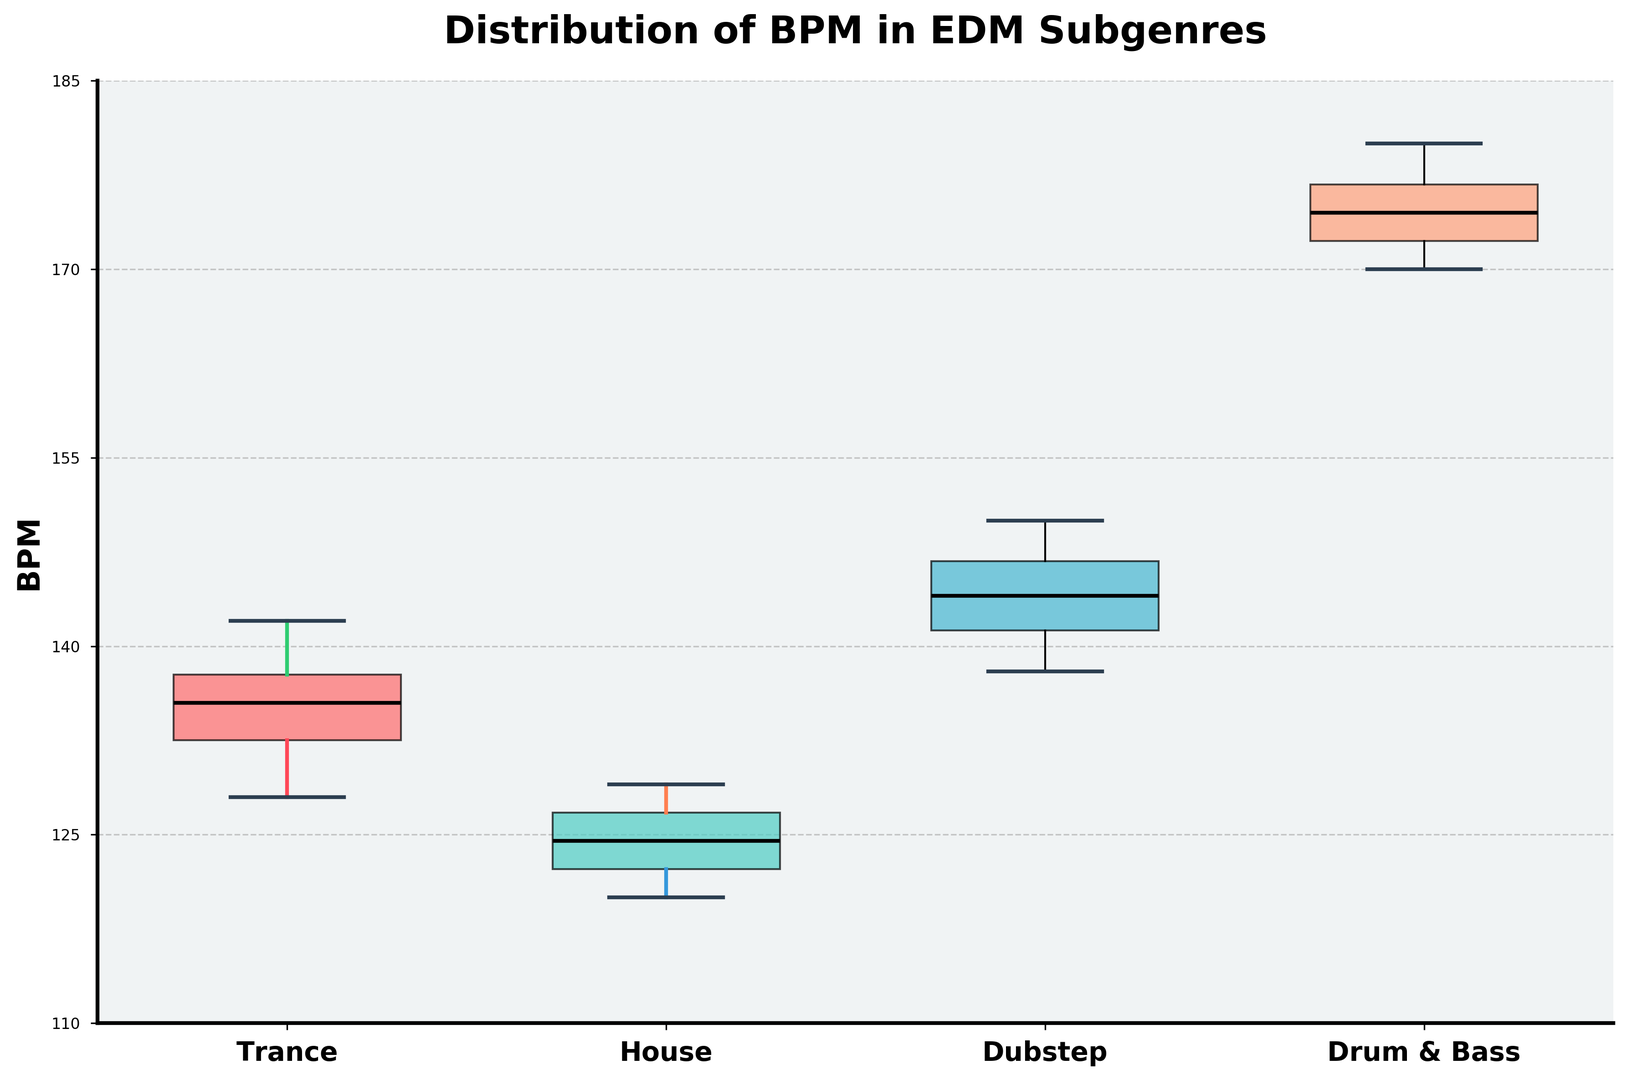What's the median BPM of the House subgenre? The median BPM is the middle value of the House subgenre when its BPM values are ordered. The ordered values are 120, 121, 122, 123, 124, 125, 126, 127, 128, 129. The median is 124.5 as it is the average of the 5th and 6th values (124 and 125).
Answer: 124.5 Which subgenre has the highest median BPM? By looking at the middle line in each box which represents the median, Drum & Bass has the highest median BPM.
Answer: Drum & Bass What is the interquartile range (IQR) of BPM for Dubstep? The interquartile range (IQR) is the difference between the 75th percentile (upper quartile) and the 25th percentile (lower quartile). For Dubstep, the lower quartile is 141 and the upper quartile is 147. Therefore, the IQR is 147 - 141 = 6 BPM.
Answer: 6 How does the variability of BPM in Trance compare to House? Variability can be observed by the length of the boxes and the spread of the whiskers. The range for Trance (130 - 140) is larger than for House (120 - 129), indicating that Trance has higher variability in BPM.
Answer: Trance has higher variability Which subgenre has the smallest range of BPM values? The range is calculated by subtracting the minimum BPM from the maximum BPM within each subgenre. Drum & Bass and Dubstep have a range of 10 BPM, House has a range of 9 BPM, and Trance has the largest range at 12 BPM. Therefore, House has the smallest range.
Answer: House Are there any subgenres with overlapping BPM ranges, and if so, which ones? By examining the box plots, we can see that Trance (range of 130-142 BPM) overlaps with Dubstep (range of 138-150 BPM).
Answer: Trance and Dubstep What is the upper whisker BPM value for Drum & Bass? The upper whisker extends to the maximum BPM value within 1.5*IQR from the upper quartile. For Drum & Bass, the upper whisker reaches the highest BPM value shown in the plot, which is 180 BPM.
Answer: 180 What color represents Dubstep in the plot? The box for Dubstep is colored in a distinct shade that differentiates it from other subgenres. It is the turquoise box.
Answer: Turquoise 